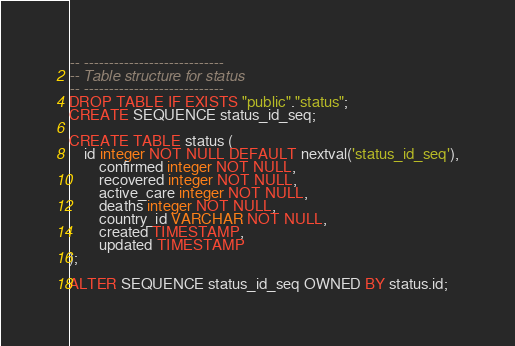<code> <loc_0><loc_0><loc_500><loc_500><_SQL_>-- ----------------------------
-- Table structure for status
-- ----------------------------
DROP TABLE IF EXISTS "public"."status";
CREATE SEQUENCE status_id_seq;

CREATE TABLE status (
    id integer NOT NULL DEFAULT nextval('status_id_seq'),
		confirmed integer NOT NULL,
		recovered integer NOT NULL,
		active_care integer NOT NULL,
		deaths integer NOT NULL,
		country_id VARCHAR NOT NULL,
		created TIMESTAMP,
		updated TIMESTAMP
);

ALTER SEQUENCE status_id_seq OWNED BY status.id;
</code> 